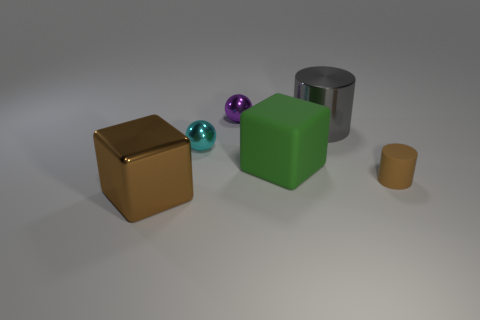What is the material of the other brown cube that is the same size as the matte cube?
Your response must be concise. Metal. How many objects are big gray rubber cylinders or cylinders in front of the small cyan sphere?
Ensure brevity in your answer.  1. There is a purple thing; is its size the same as the block that is to the right of the cyan thing?
Keep it short and to the point. No. What number of spheres are large cyan things or tiny cyan shiny things?
Ensure brevity in your answer.  1. What number of objects are in front of the green rubber cube and left of the large gray shiny cylinder?
Make the answer very short. 1. How many other things are there of the same color as the large metallic cube?
Make the answer very short. 1. There is a brown object that is behind the large metallic cube; what shape is it?
Give a very brief answer. Cylinder. Are the green object and the tiny purple ball made of the same material?
Your response must be concise. No. Is there any other thing that has the same size as the green matte thing?
Make the answer very short. Yes. There is a small brown rubber cylinder; what number of large blocks are in front of it?
Your answer should be compact. 1. 